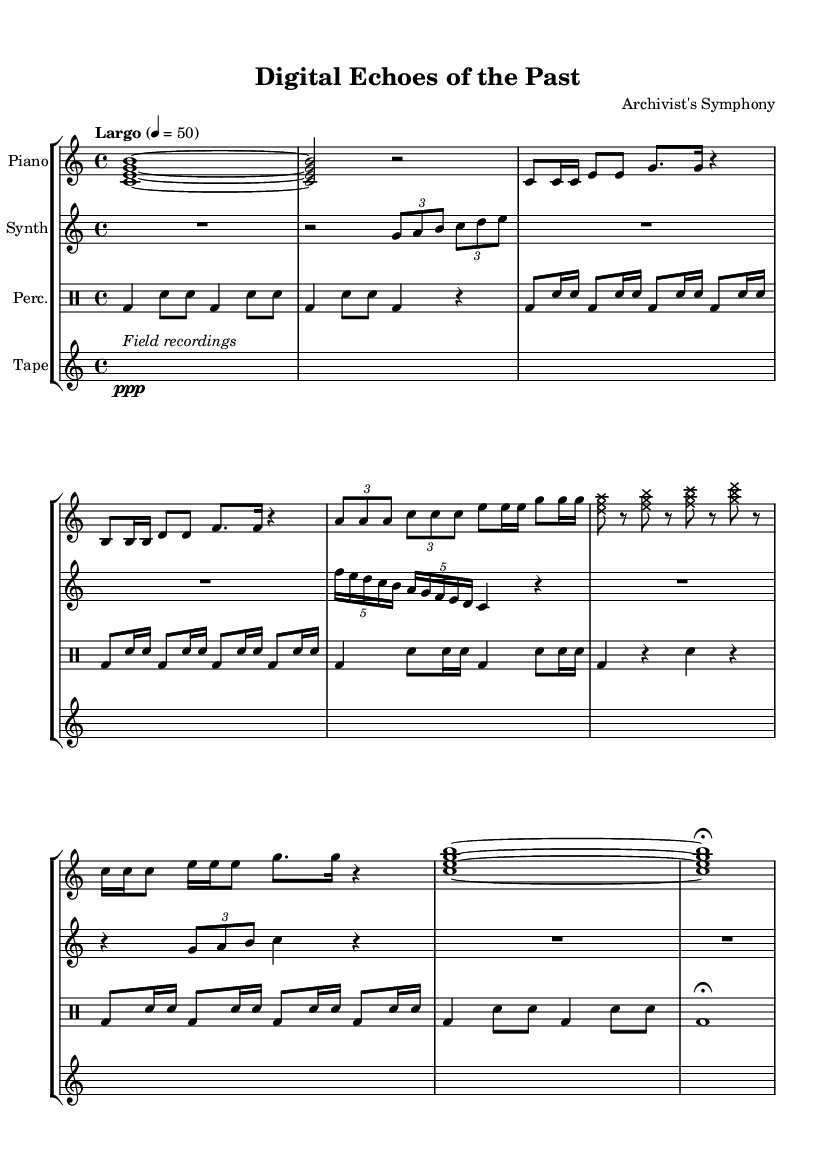What is the time signature of this music? The time signature is located near the beginning of the score; it shows four beats per measure, indicating a time signature of 4/4.
Answer: 4/4 What tempo marking is indicated in the score? The tempo marking can be found in the global section at the beginning of the score, where it states "Largo" with a specified beat of 50.
Answer: Largo 4 = 50 How many sections does the piece have? By examining the structure of the music, we can identify four distinct sections: Introduction, Section A, Section B, and Interlude, with variations and a coda.
Answer: Four In which instrument is the Morse code-inspired melody played? The specific melodic lines that represent Morse code can be found in the piano part, where the rhythm and notes suggest this influence.
Answer: Piano What style is used in the interlude for the prepared piano? The interlude indicates a different technique through the note head style being overridden to 'cross', suggesting a prepared piano approach.
Answer: Cross What notation indicates a field recording representation? The representation of field recordings is indicated by the use of silent measures labeled with a ppp dynamic and an italicized description in the tape recorder part.
Answer: Field recordings Which section features a binary code-inspired rhythm? The binary code-inspired rhythm is located in Section B, where a structured and repetitive rhythmic pattern that aligns with binary representation is evident.
Answer: Section B 